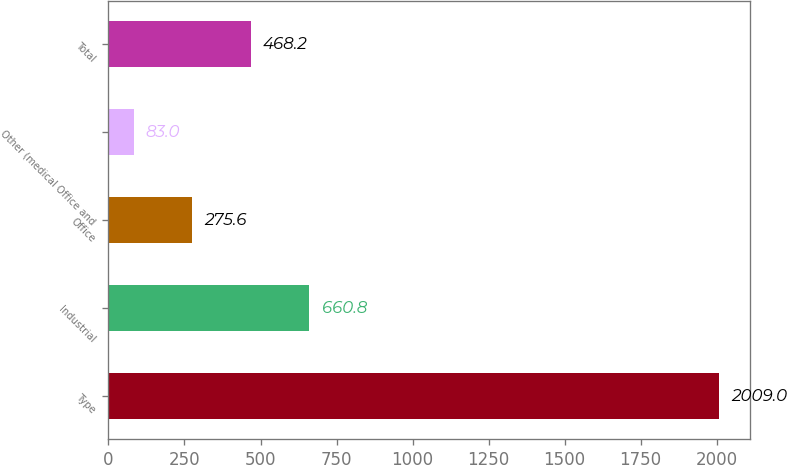<chart> <loc_0><loc_0><loc_500><loc_500><bar_chart><fcel>Type<fcel>Industrial<fcel>Office<fcel>Other (medical Office and<fcel>Total<nl><fcel>2009<fcel>660.8<fcel>275.6<fcel>83<fcel>468.2<nl></chart> 